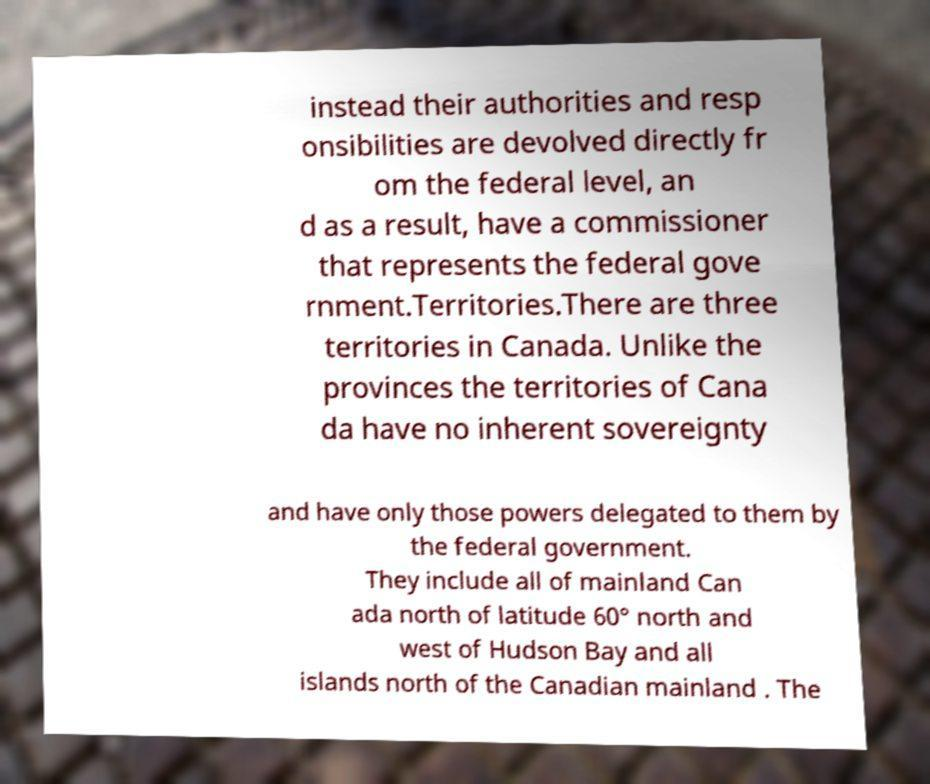Can you read and provide the text displayed in the image?This photo seems to have some interesting text. Can you extract and type it out for me? instead their authorities and resp onsibilities are devolved directly fr om the federal level, an d as a result, have a commissioner that represents the federal gove rnment.Territories.There are three territories in Canada. Unlike the provinces the territories of Cana da have no inherent sovereignty and have only those powers delegated to them by the federal government. They include all of mainland Can ada north of latitude 60° north and west of Hudson Bay and all islands north of the Canadian mainland . The 